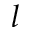<formula> <loc_0><loc_0><loc_500><loc_500>l</formula> 